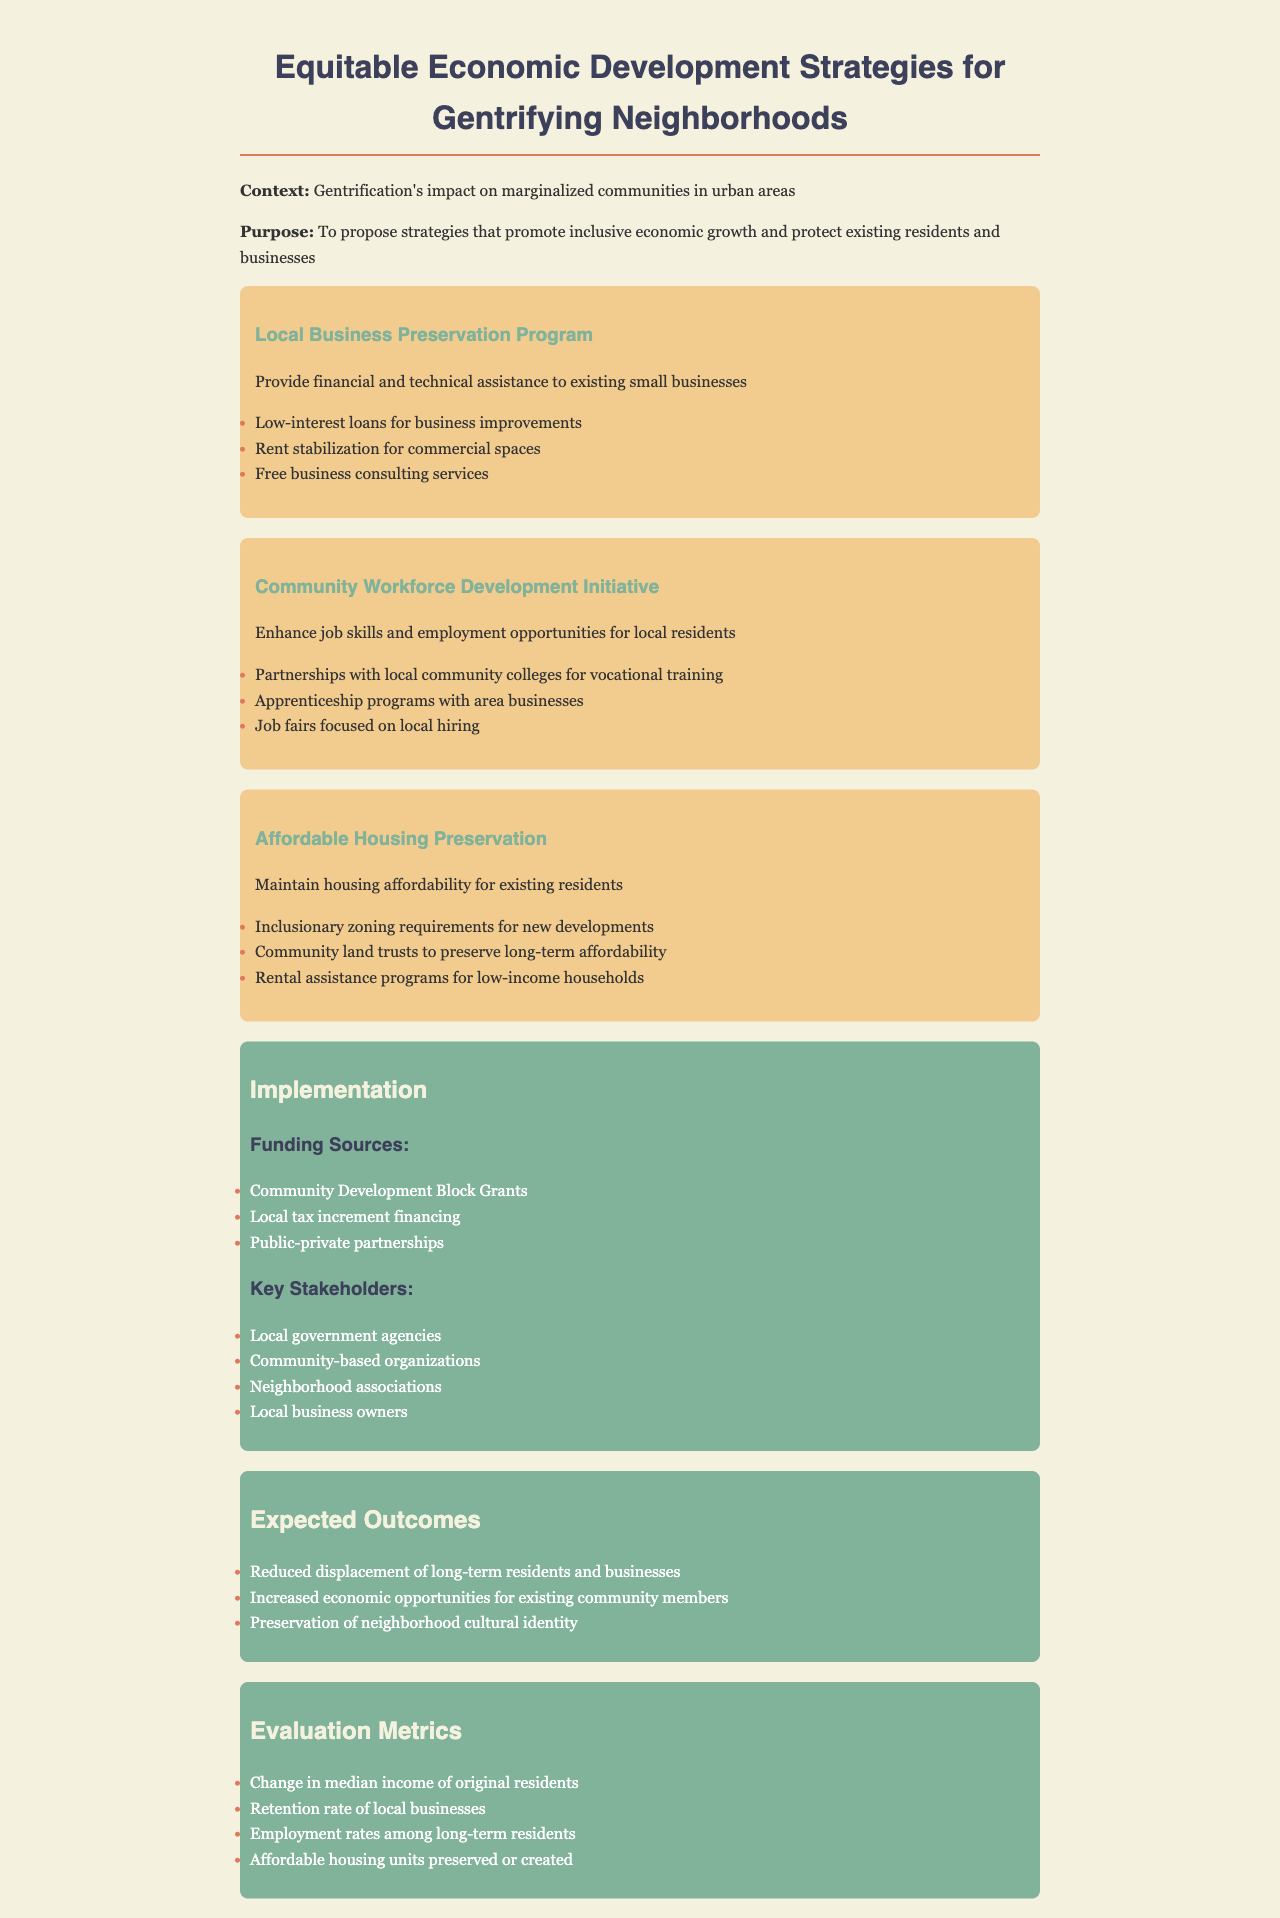What is the title of the document? The title is mentioned at the beginning of the document under the <title> tag.
Answer: Equitable Economic Development Strategies What strategy focuses on local businesses? The relevant section outlines specific actions to support local businesses in the document.
Answer: Local Business Preservation Program Which stakeholders are key to implementation? The stakeholders are listed in a dedicated section of the document that discusses implementation.
Answer: Local government agencies, community-based organizations, neighborhood associations, local business owners What type of program is proposed for job skills enhancement? The document describes a specific initiative aimed at improving job skills for community members.
Answer: Community Workforce Development Initiative What funding source is mentioned for supporting these strategies? Funding sources are outlined in the implementation section of the document.
Answer: Community Development Block Grants What is an expected outcome of these strategies? The document lists several anticipated results from implementing the proposed strategies.
Answer: Reduced displacement of long-term residents and businesses How is housing affordability maintained according to the document? The strategies for maintaining housing affordability are outlined in a specific section.
Answer: Inclusionary zoning requirements for new developments What metrics measure the success of the initiatives? The document details metrics used to evaluate the success of the proposed policies.
Answer: Change in median income of original residents 